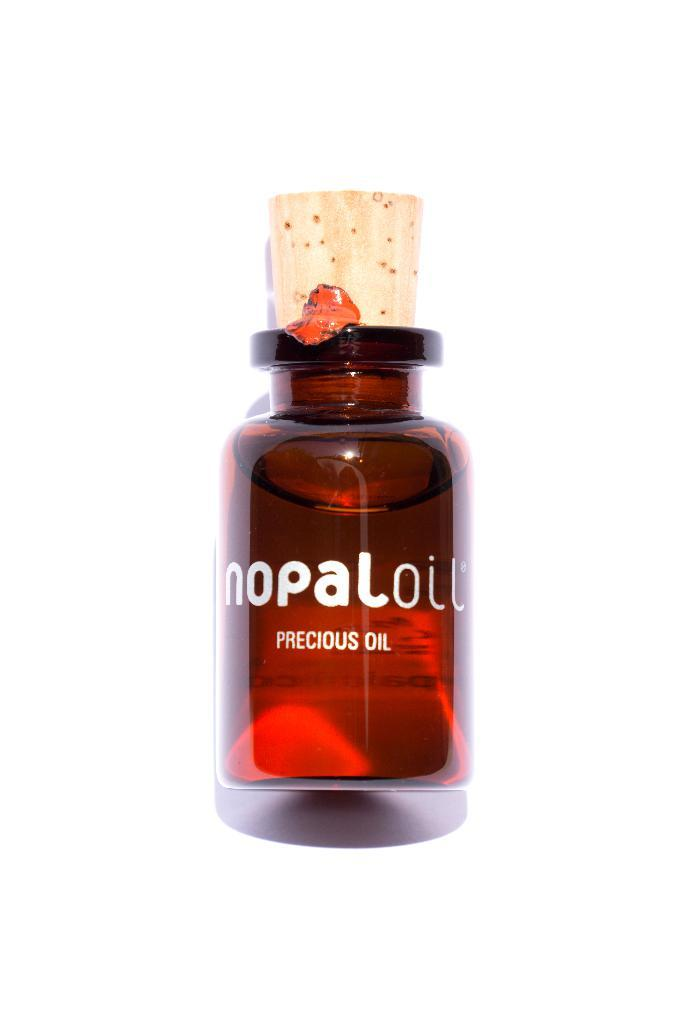<image>
Render a clear and concise summary of the photo. An amber bottle with a cork that says nopaloil precious oil. 